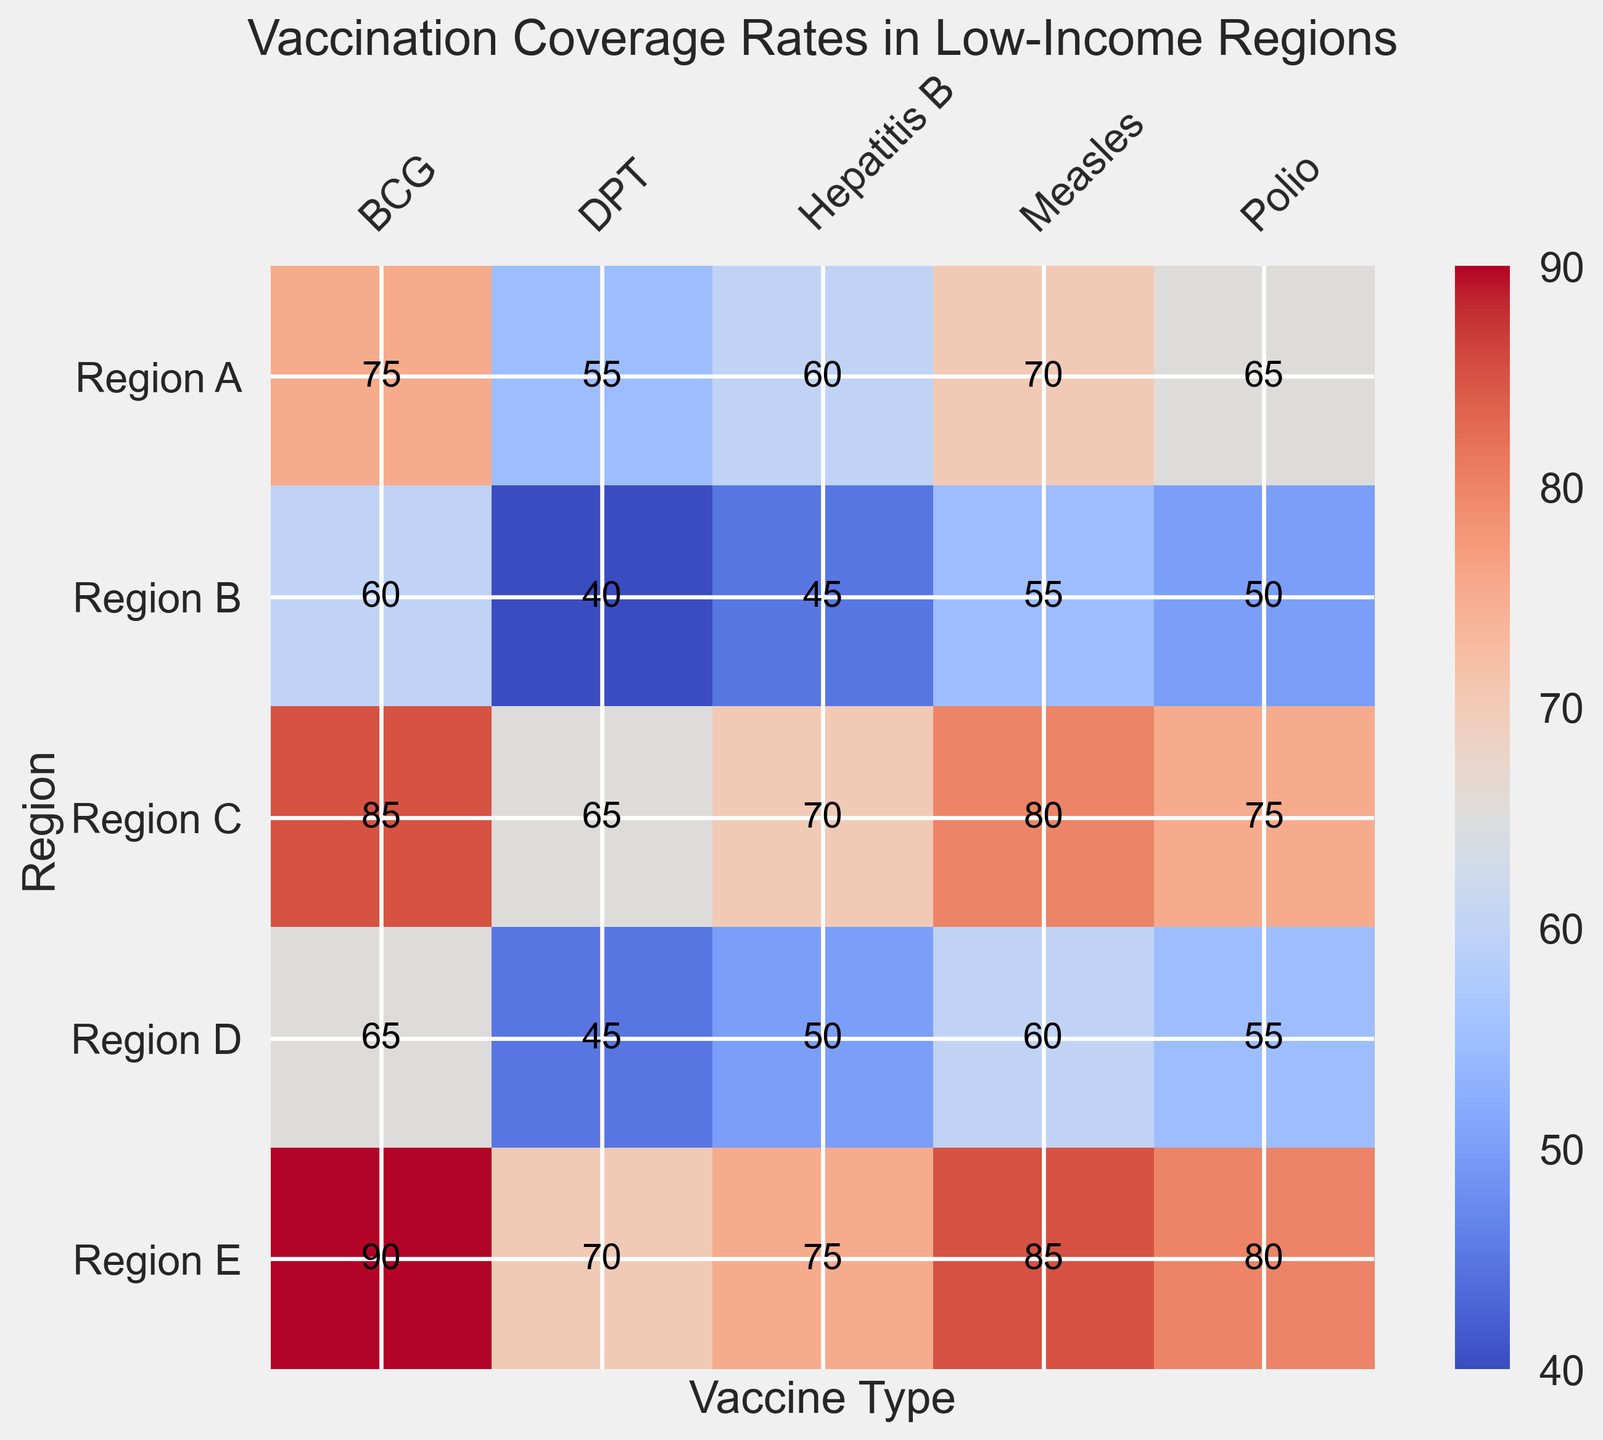what's the average vaccination coverage rate for Region A? To find the average vaccination coverage rate for Region A, first add up all the coverage rates: 65 (Polio) + 70 (Measles) + 60 (Hepatitis B) + 55 (DPT) + 75 (BCG) = 325. Next, divide by the number of vaccine types (5): 325 / 5 = 65
Answer: 65 Which vaccine type in Region B has the lowest coverage rate? Look at the coverage rates for different vaccine types in Region B. Polio (50), Measles (55), Hepatitis B (45), DPT (40), and BCG (60). The lowest value is for DPT, which is 40
Answer: DPT How much higher is the BCG coverage rate in Region E compared to Region A? The BCG coverage rate in Region E is 90, and in Region A it is 75. Subtract the two values: 90 - 75 = 15
Answer: 15 What is the highest overall vaccination coverage rate? Scan the heatmap for the largest value. The highest value is found under Region E for BCG, which is 90
Answer: 90 Which region has the most consistent (least variation) vaccination coverage rates? To determine consistency, check the differences between the highest and lowest coverage rates for each region. Calculate the range for each region: 
Region A: highest 75, lowest 55, range 75-55=20
Region B: highest 60, lowest 40, range 60-40=20
Region C: highest 85, lowest 65, range 85-65=20
Region D: highest 65, lowest 45, range 65-45=20
Region E: highest 90, lowest 70, range 90-70=20
All regions have the same range of 20, so they all have the same level of consistency.
Answer: All regions have the same consistency Compare the average coverage rate of Polio and DPT vaccines across all regions. Which is higher and by how much? Calculate the average for each vaccine:
Polio: (65 + 50 + 75 + 55 + 80) / 5 = 65, DPT: (55 + 40 + 65 + 45 + 70) / 5 = 55.
Now, find the difference: 65 - 55 = 10
Answer: Polio by 10 What visual pattern can you see in the heatmap for the BCG vaccine coverage across regions? The BCG vaccine has the highest coverage rate in each region compared to other vaccines
Answer: BCG has the highest coverage in all regions Which two regions have the smallest difference in Measles vaccination coverage rates? Compare the Measles coverage rates:
Region A - 70, Region B - 55, Region C - 80, Region D - 60, Region E - 85.
The smallest difference is between Region A (70) and Region D (60): 70 - 60 = 10
Answer: Region A and Region D 